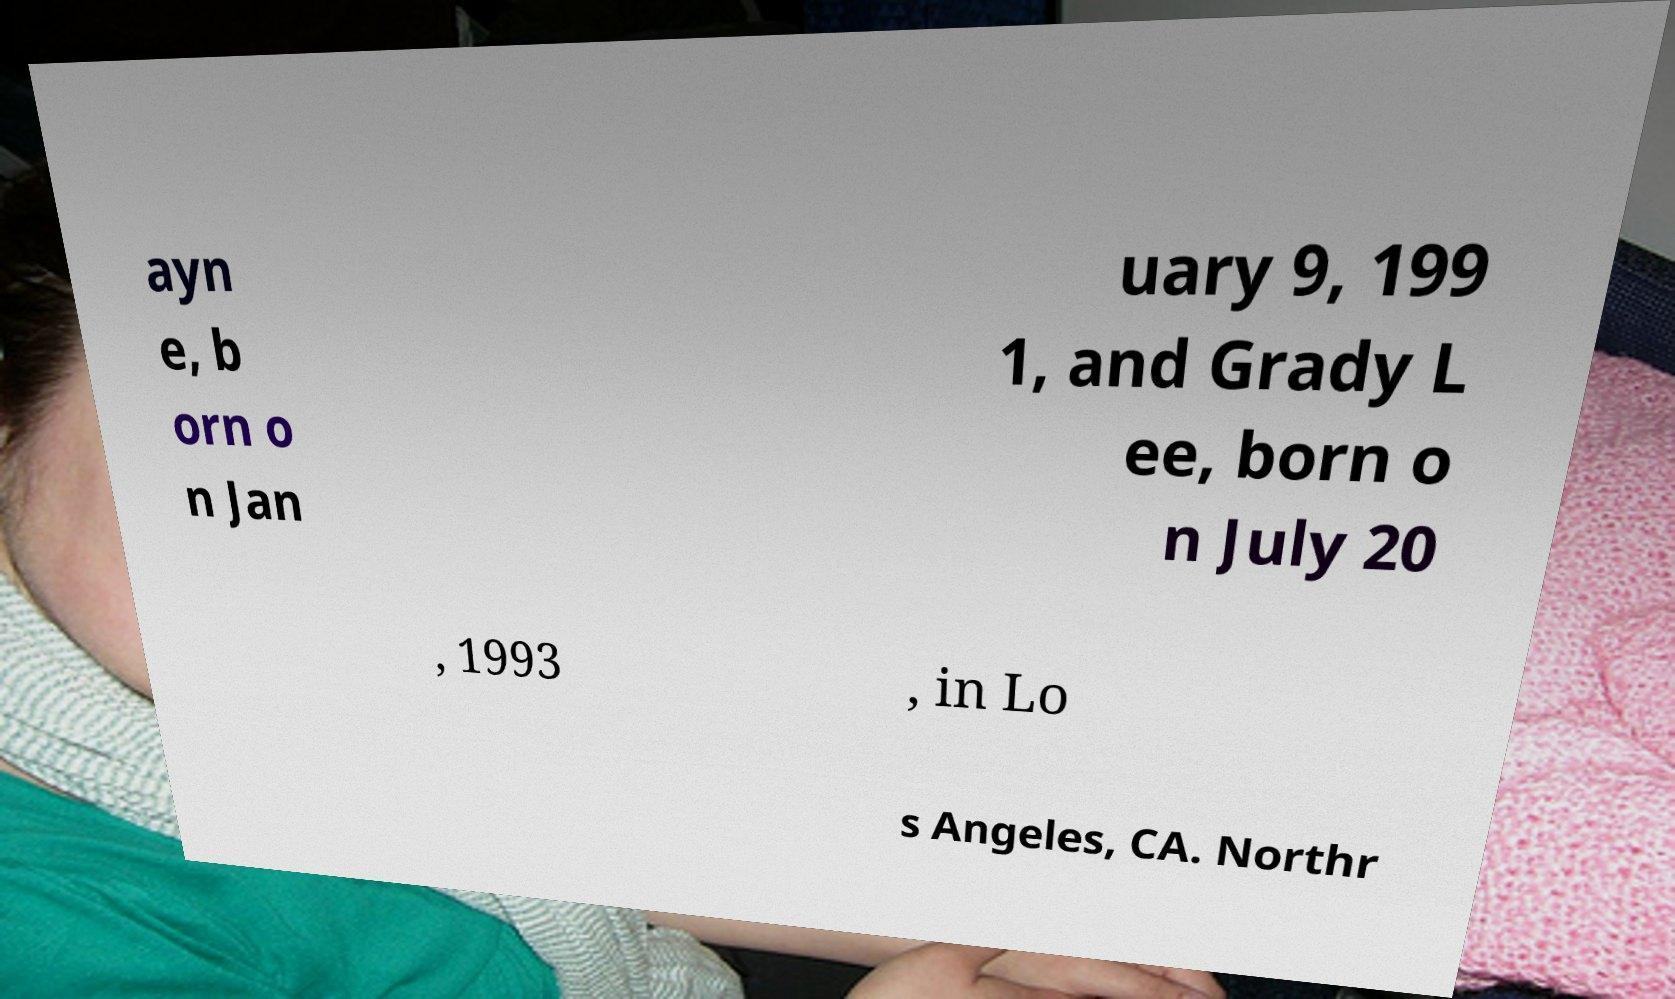Could you assist in decoding the text presented in this image and type it out clearly? ayn e, b orn o n Jan uary 9, 199 1, and Grady L ee, born o n July 20 , 1993 , in Lo s Angeles, CA. Northr 